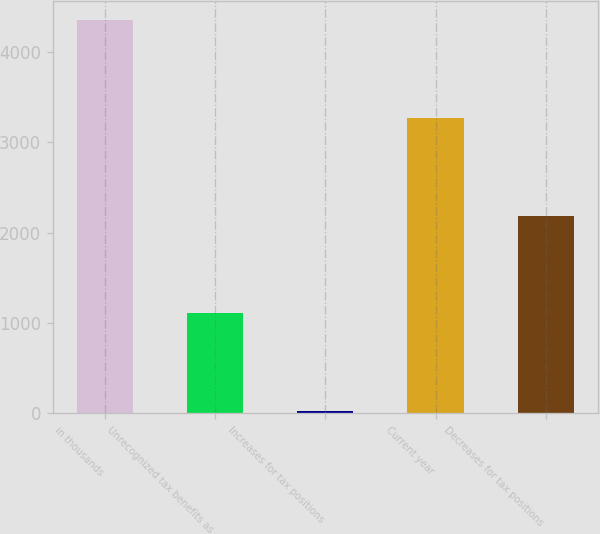Convert chart to OTSL. <chart><loc_0><loc_0><loc_500><loc_500><bar_chart><fcel>in thousands<fcel>Unrecognized tax benefits as<fcel>Increases for tax positions<fcel>Current year<fcel>Decreases for tax positions<nl><fcel>4347.4<fcel>1107.1<fcel>27<fcel>3267.3<fcel>2187.2<nl></chart> 